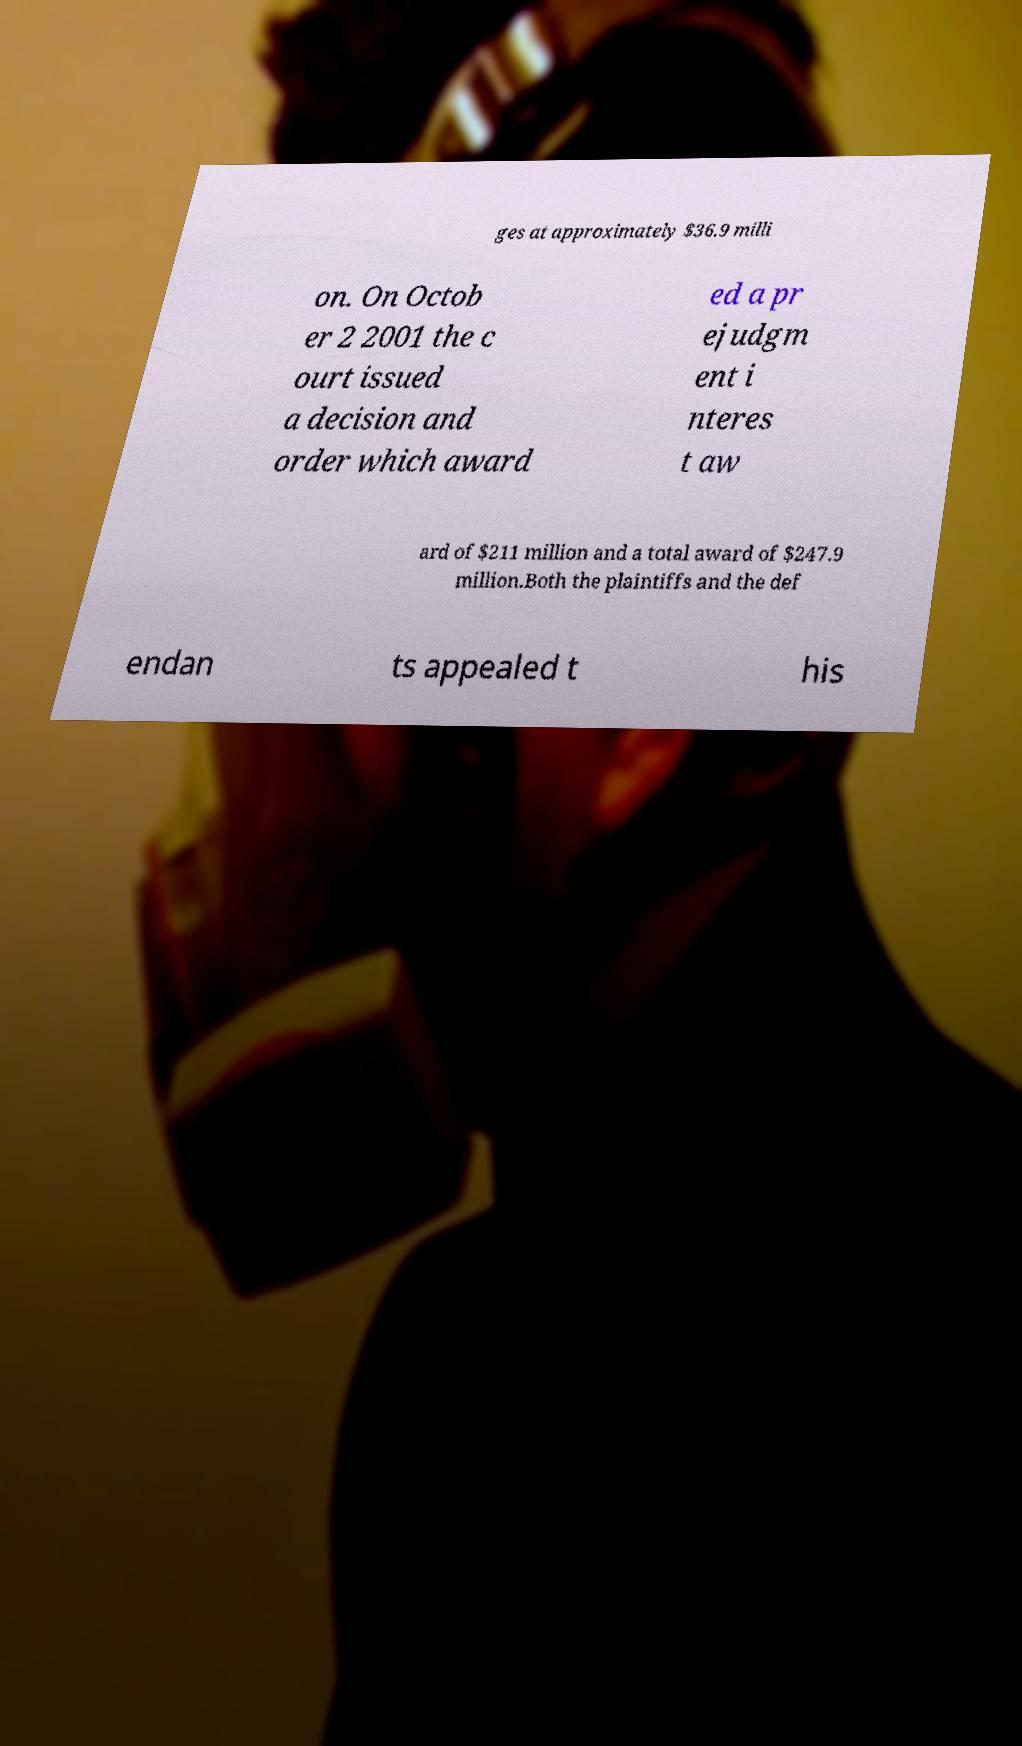There's text embedded in this image that I need extracted. Can you transcribe it verbatim? ges at approximately $36.9 milli on. On Octob er 2 2001 the c ourt issued a decision and order which award ed a pr ejudgm ent i nteres t aw ard of $211 million and a total award of $247.9 million.Both the plaintiffs and the def endan ts appealed t his 